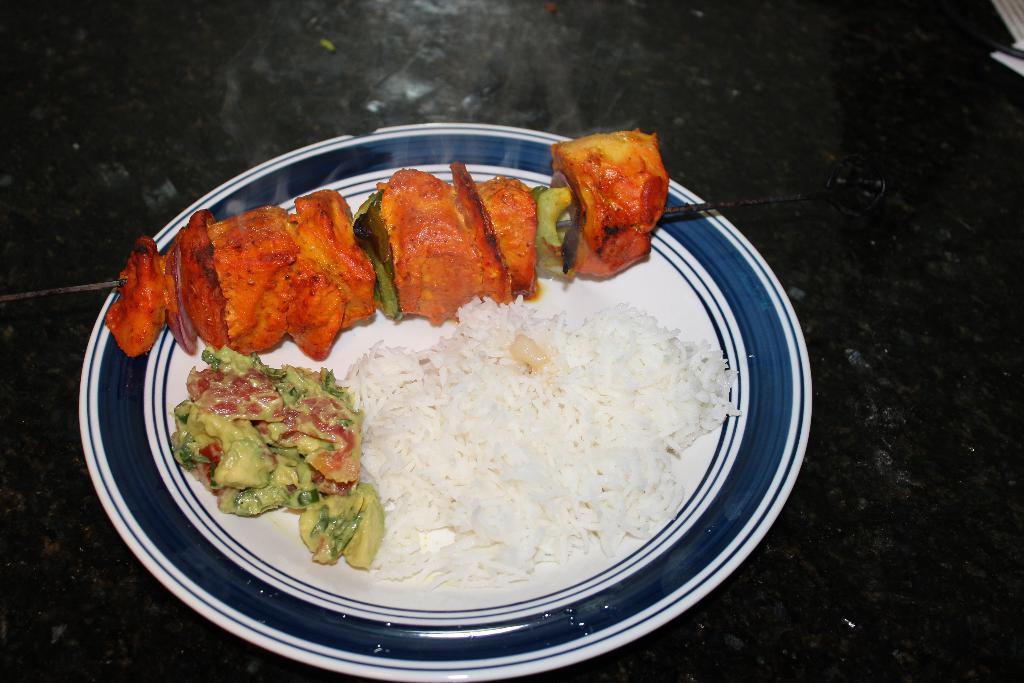Please provide a concise description of this image. In the picture we can see a plate with some rice, curry which is yellow in color and beside it we can see some roasted meat to the stick. 